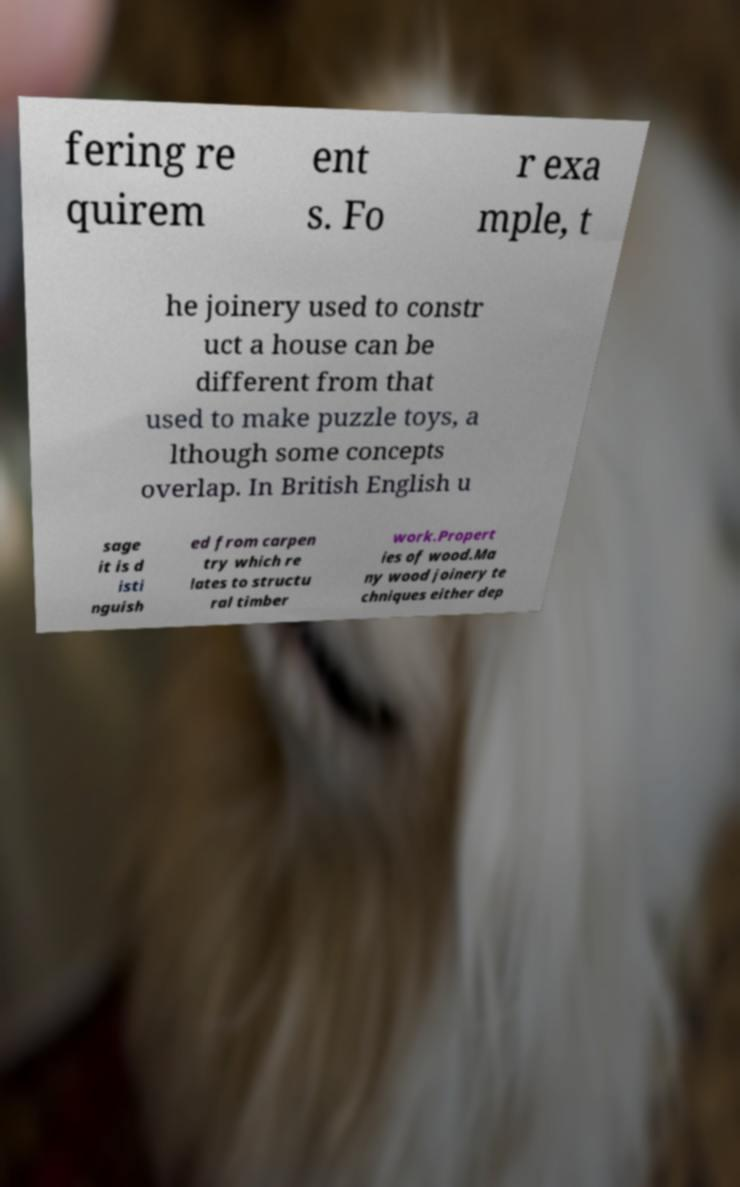Please read and relay the text visible in this image. What does it say? fering re quirem ent s. Fo r exa mple, t he joinery used to constr uct a house can be different from that used to make puzzle toys, a lthough some concepts overlap. In British English u sage it is d isti nguish ed from carpen try which re lates to structu ral timber work.Propert ies of wood.Ma ny wood joinery te chniques either dep 